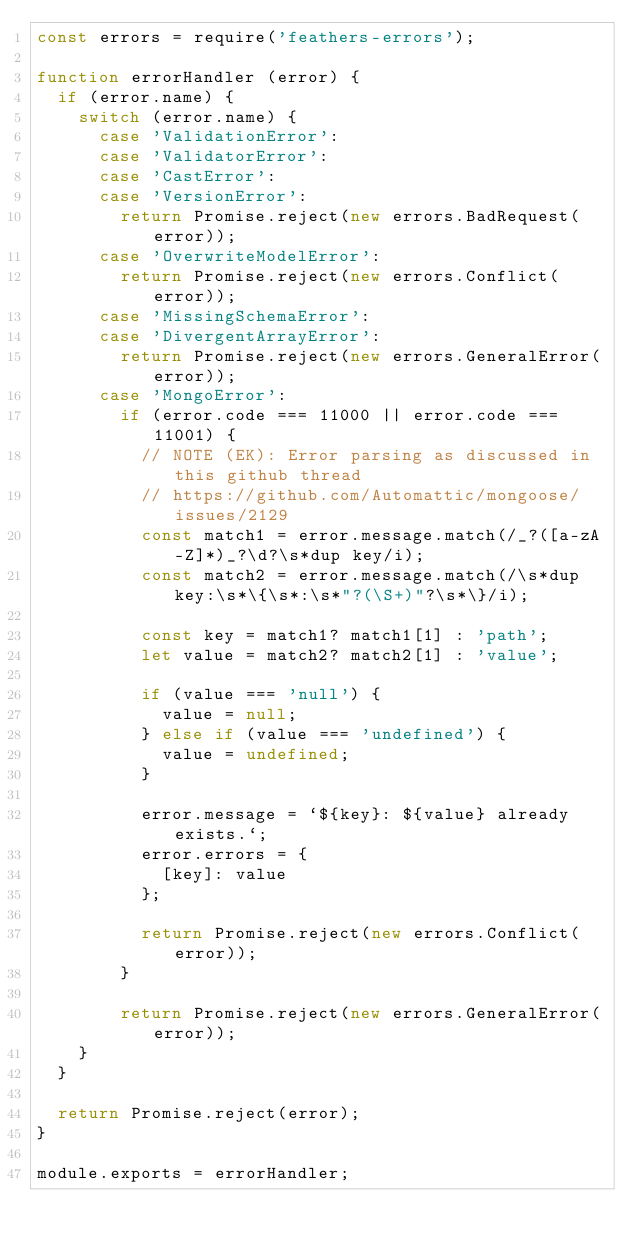Convert code to text. <code><loc_0><loc_0><loc_500><loc_500><_JavaScript_>const errors = require('feathers-errors');

function errorHandler (error) {
  if (error.name) {
    switch (error.name) {
      case 'ValidationError':
      case 'ValidatorError':
      case 'CastError':
      case 'VersionError':
        return Promise.reject(new errors.BadRequest(error));
      case 'OverwriteModelError':
        return Promise.reject(new errors.Conflict(error));
      case 'MissingSchemaError':
      case 'DivergentArrayError':
        return Promise.reject(new errors.GeneralError(error));
      case 'MongoError':
        if (error.code === 11000 || error.code === 11001) {
          // NOTE (EK): Error parsing as discussed in this github thread
          // https://github.com/Automattic/mongoose/issues/2129
          const match1 = error.message.match(/_?([a-zA-Z]*)_?\d?\s*dup key/i);
          const match2 = error.message.match(/\s*dup key:\s*\{\s*:\s*"?(\S+)"?\s*\}/i);

          const key = match1? match1[1] : 'path';
          let value = match2? match2[1] : 'value';

          if (value === 'null') {
            value = null;
          } else if (value === 'undefined') {
            value = undefined;
          }

          error.message = `${key}: ${value} already exists.`;
          error.errors = {
            [key]: value
          };

          return Promise.reject(new errors.Conflict(error));
        }

        return Promise.reject(new errors.GeneralError(error));
    }
  }

  return Promise.reject(error);
}

module.exports = errorHandler;</code> 